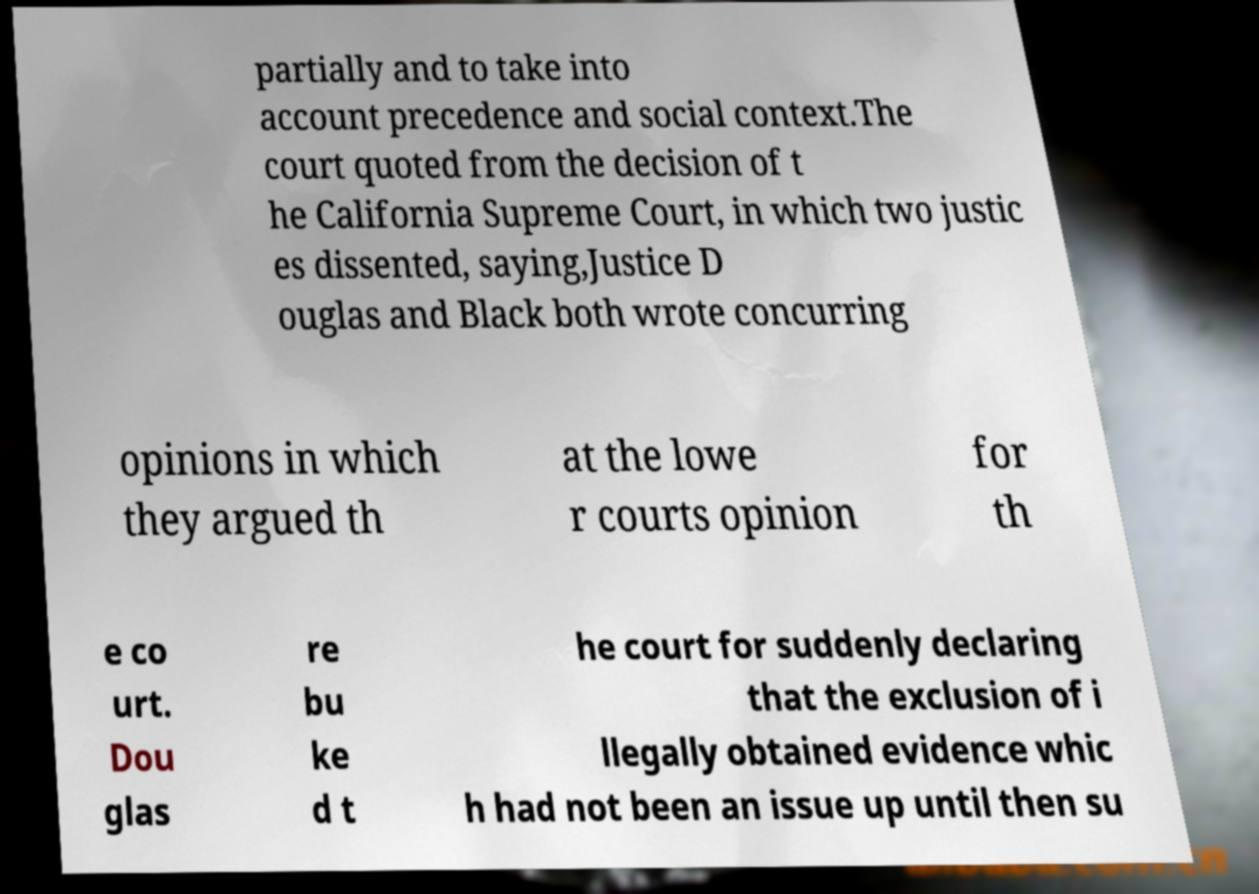Please identify and transcribe the text found in this image. partially and to take into account precedence and social context.The court quoted from the decision of t he California Supreme Court, in which two justic es dissented, saying,Justice D ouglas and Black both wrote concurring opinions in which they argued th at the lowe r courts opinion for th e co urt. Dou glas re bu ke d t he court for suddenly declaring that the exclusion of i llegally obtained evidence whic h had not been an issue up until then su 